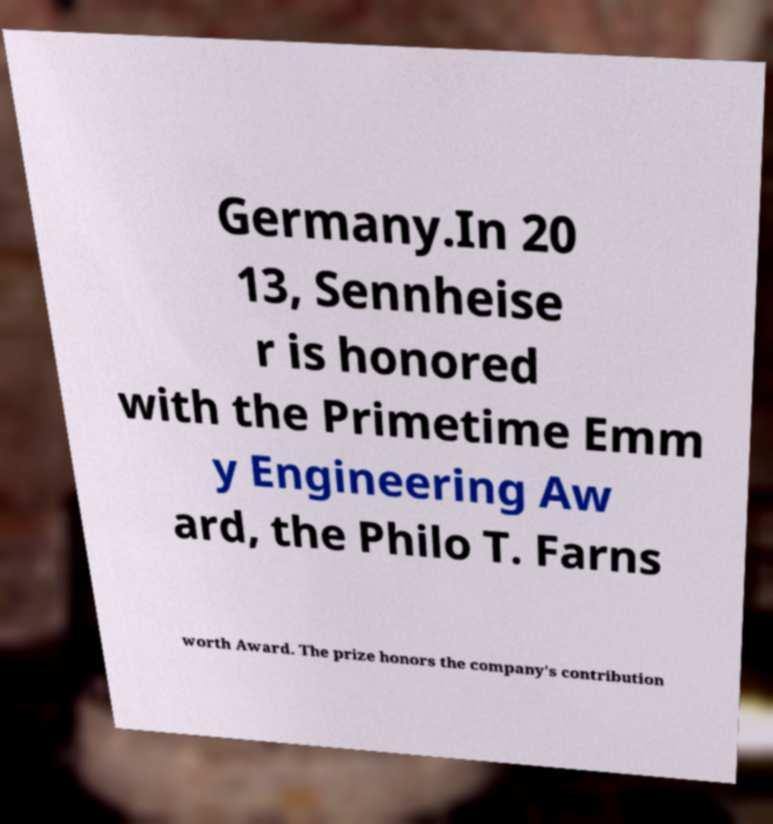Could you extract and type out the text from this image? Germany.In 20 13, Sennheise r is honored with the Primetime Emm y Engineering Aw ard, the Philo T. Farns worth Award. The prize honors the company's contribution 